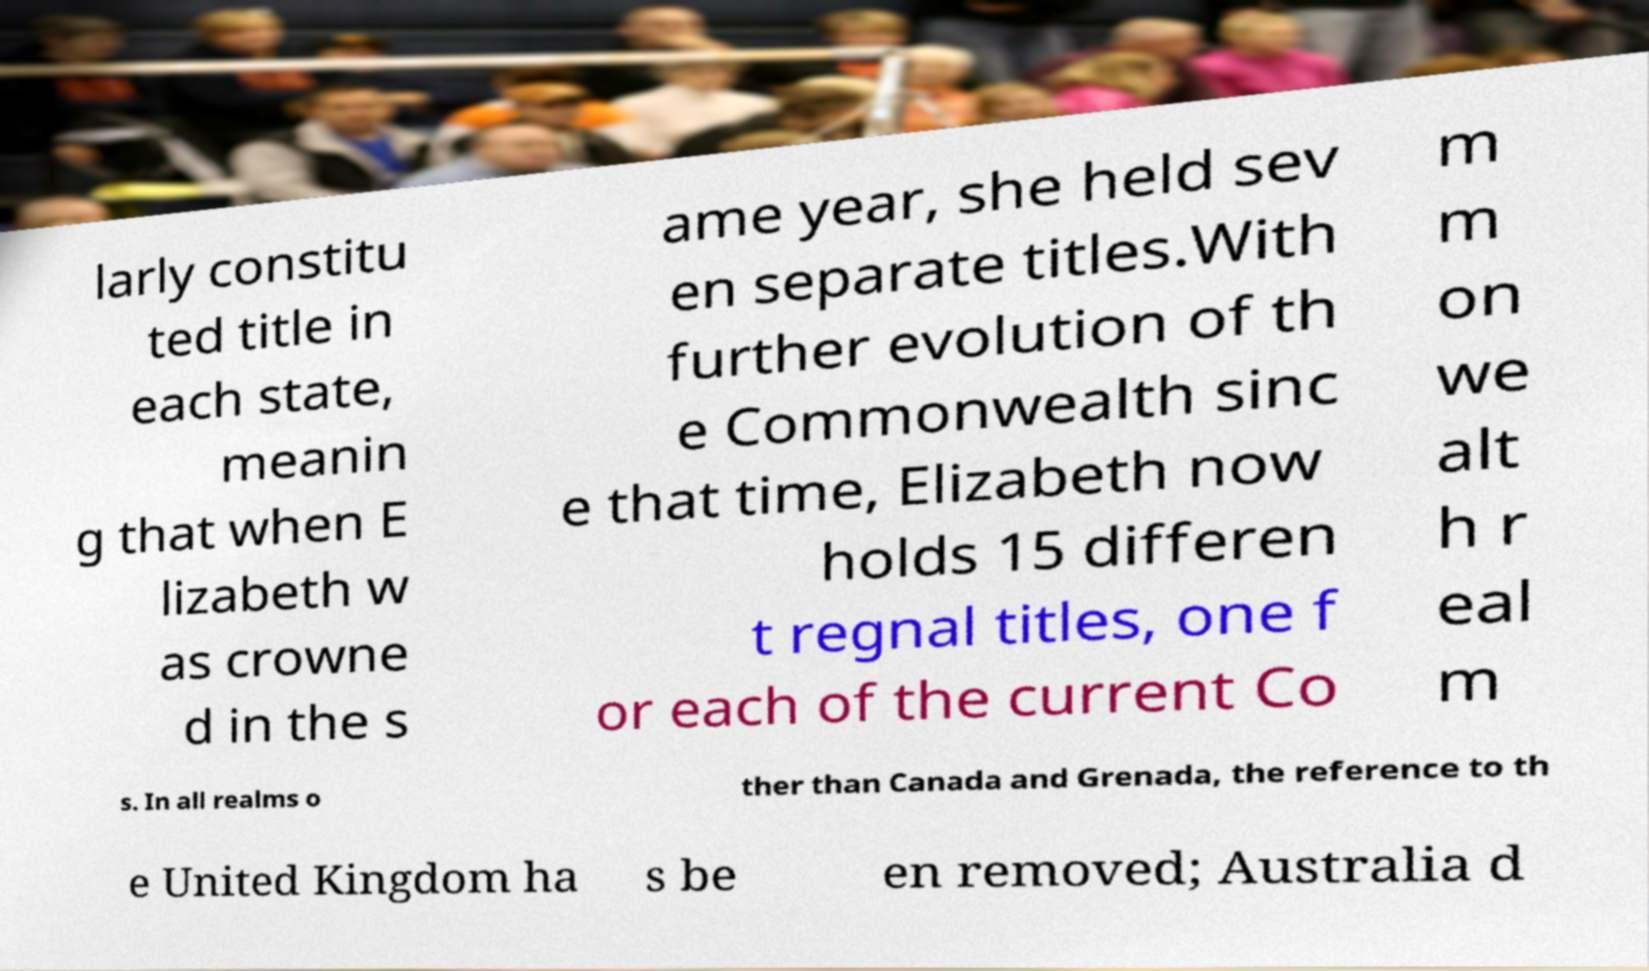There's text embedded in this image that I need extracted. Can you transcribe it verbatim? larly constitu ted title in each state, meanin g that when E lizabeth w as crowne d in the s ame year, she held sev en separate titles.With further evolution of th e Commonwealth sinc e that time, Elizabeth now holds 15 differen t regnal titles, one f or each of the current Co m m on we alt h r eal m s. In all realms o ther than Canada and Grenada, the reference to th e United Kingdom ha s be en removed; Australia d 